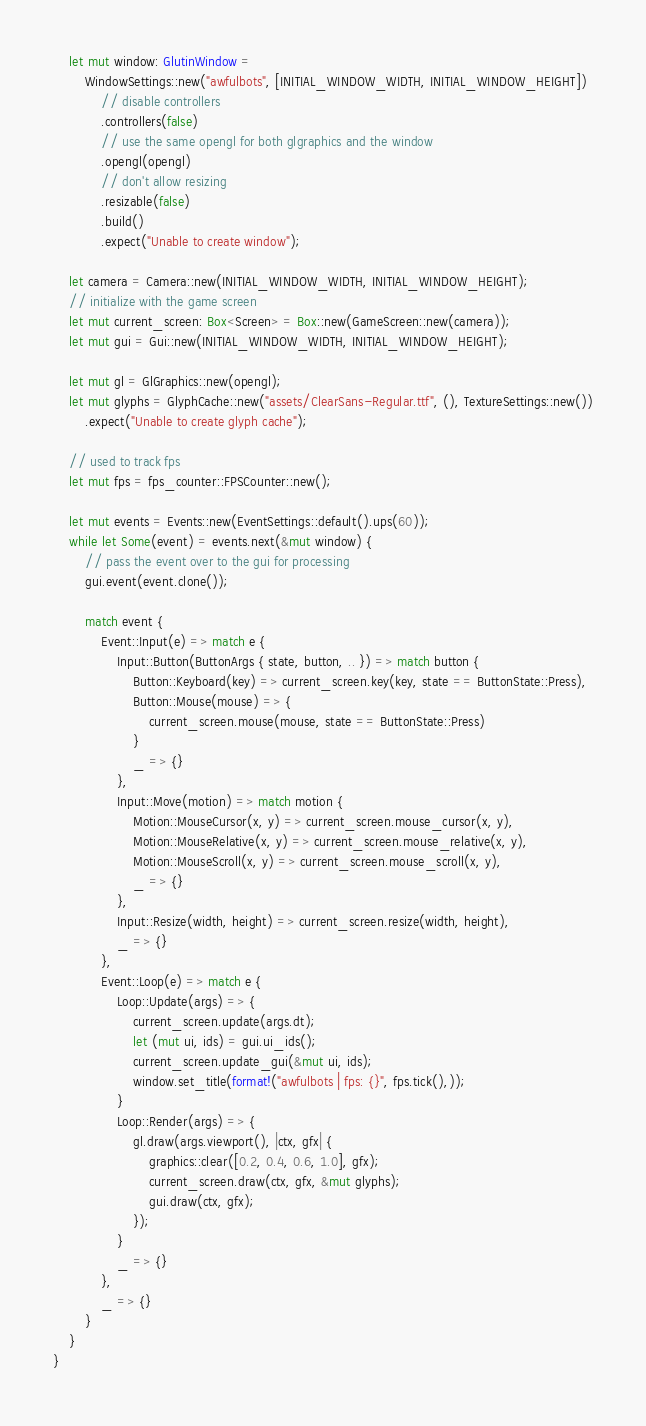<code> <loc_0><loc_0><loc_500><loc_500><_Rust_>    let mut window: GlutinWindow =
        WindowSettings::new("awfulbots", [INITIAL_WINDOW_WIDTH, INITIAL_WINDOW_HEIGHT])
            // disable controllers
            .controllers(false)
            // use the same opengl for both glgraphics and the window
            .opengl(opengl)
            // don't allow resizing
            .resizable(false)
            .build()
            .expect("Unable to create window");

    let camera = Camera::new(INITIAL_WINDOW_WIDTH, INITIAL_WINDOW_HEIGHT);
    // initialize with the game screen
    let mut current_screen: Box<Screen> = Box::new(GameScreen::new(camera));
    let mut gui = Gui::new(INITIAL_WINDOW_WIDTH, INITIAL_WINDOW_HEIGHT);

    let mut gl = GlGraphics::new(opengl);
    let mut glyphs = GlyphCache::new("assets/ClearSans-Regular.ttf", (), TextureSettings::new())
        .expect("Unable to create glyph cache");

    // used to track fps
    let mut fps = fps_counter::FPSCounter::new();

    let mut events = Events::new(EventSettings::default().ups(60));
    while let Some(event) = events.next(&mut window) {
        // pass the event over to the gui for processing
        gui.event(event.clone());

        match event {
            Event::Input(e) => match e {
                Input::Button(ButtonArgs { state, button, .. }) => match button {
                    Button::Keyboard(key) => current_screen.key(key, state == ButtonState::Press),
                    Button::Mouse(mouse) => {
                        current_screen.mouse(mouse, state == ButtonState::Press)
                    }
                    _ => {}
                },
                Input::Move(motion) => match motion {
                    Motion::MouseCursor(x, y) => current_screen.mouse_cursor(x, y),
                    Motion::MouseRelative(x, y) => current_screen.mouse_relative(x, y),
                    Motion::MouseScroll(x, y) => current_screen.mouse_scroll(x, y),
                    _ => {}
                },
                Input::Resize(width, height) => current_screen.resize(width, height),
                _ => {}
            },
            Event::Loop(e) => match e {
                Loop::Update(args) => {
                    current_screen.update(args.dt);
                    let (mut ui, ids) = gui.ui_ids();
                    current_screen.update_gui(&mut ui, ids);
                    window.set_title(format!("awfulbots | fps: {}", fps.tick(),));
                }
                Loop::Render(args) => {
                    gl.draw(args.viewport(), |ctx, gfx| {
                        graphics::clear([0.2, 0.4, 0.6, 1.0], gfx);
                        current_screen.draw(ctx, gfx, &mut glyphs);
                        gui.draw(ctx, gfx);
                    });
                }
                _ => {}
            },
            _ => {}
        }
    }
}
</code> 